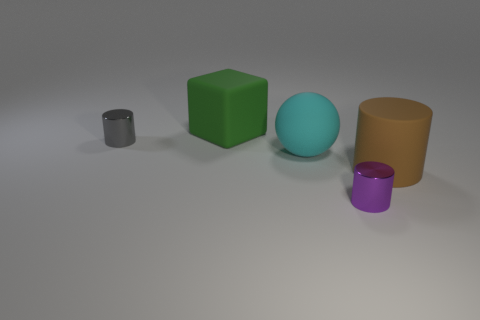Add 3 tiny shiny things. How many objects exist? 8 Subtract all cylinders. How many objects are left? 2 Add 2 purple objects. How many purple objects exist? 3 Subtract 1 cyan spheres. How many objects are left? 4 Subtract all red shiny cylinders. Subtract all green things. How many objects are left? 4 Add 5 large spheres. How many large spheres are left? 6 